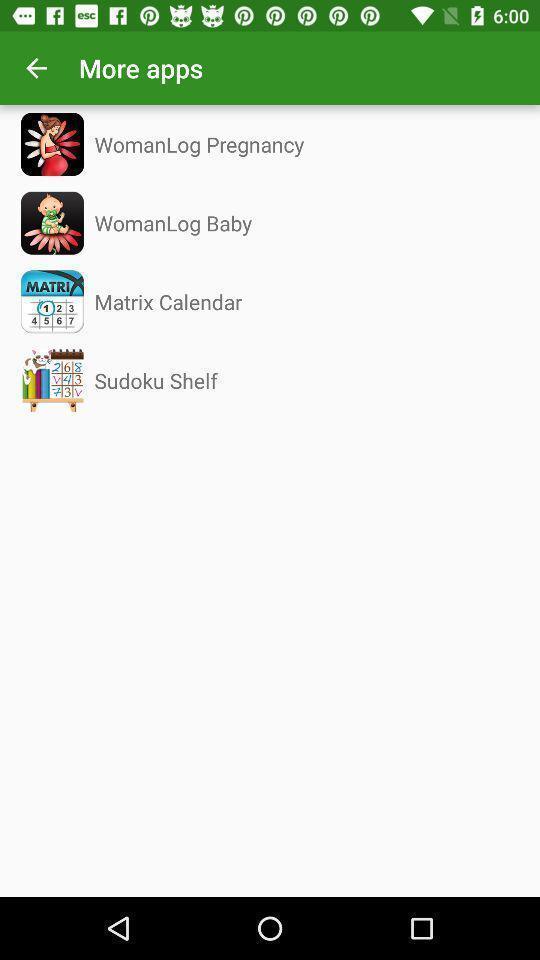Provide a detailed account of this screenshot. Screen shows about more apps. 